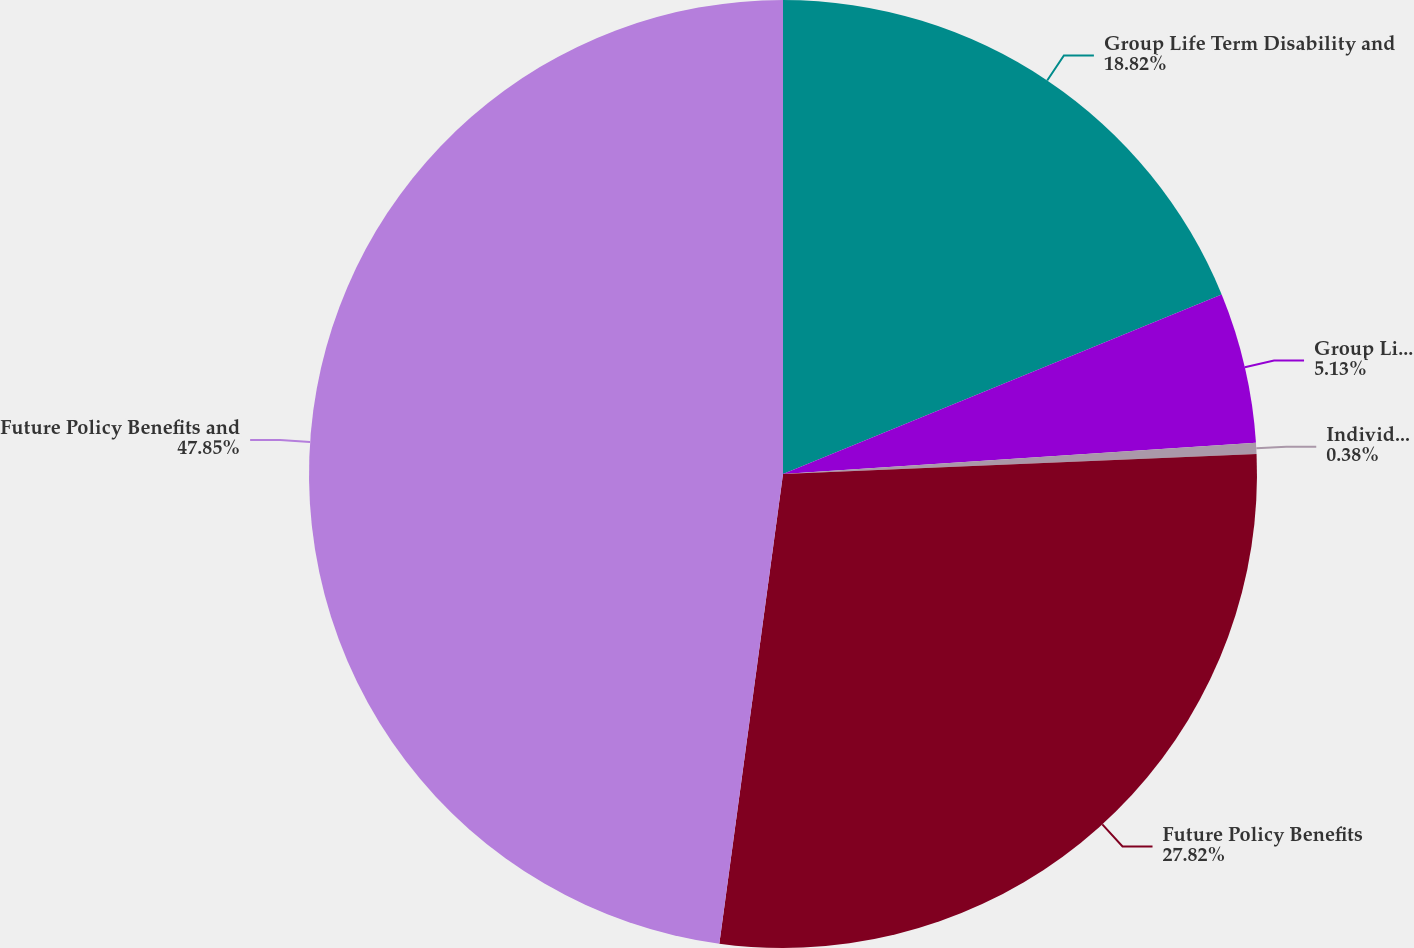<chart> <loc_0><loc_0><loc_500><loc_500><pie_chart><fcel>Group Life Term Disability and<fcel>Group Life Other unpaid losses<fcel>Individual Life unpaid losses<fcel>Future Policy Benefits<fcel>Future Policy Benefits and<nl><fcel>18.82%<fcel>5.13%<fcel>0.38%<fcel>27.82%<fcel>47.86%<nl></chart> 